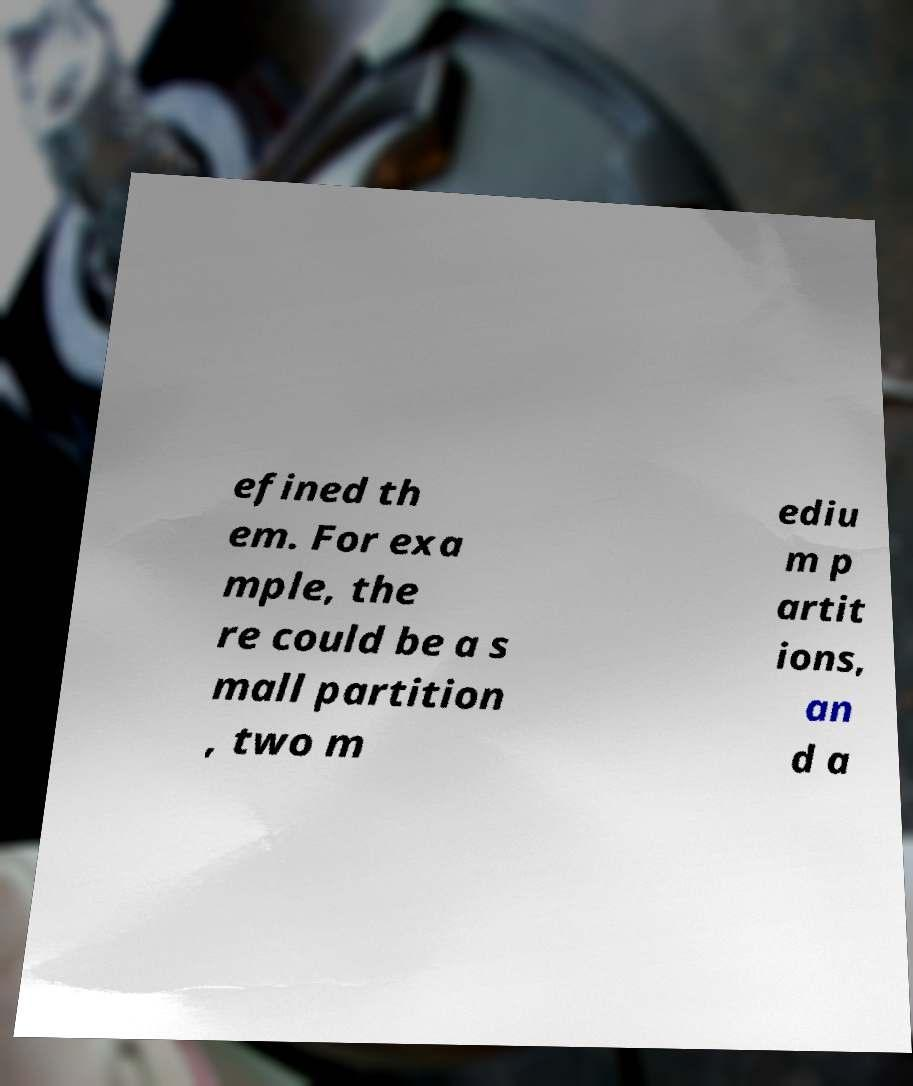Please identify and transcribe the text found in this image. efined th em. For exa mple, the re could be a s mall partition , two m ediu m p artit ions, an d a 